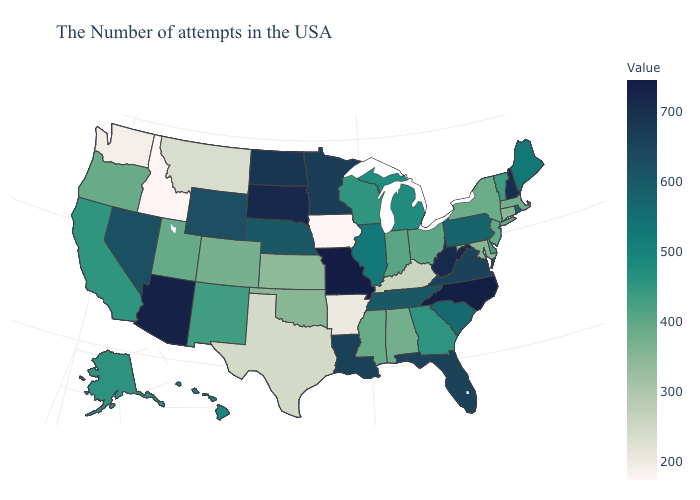Does Iowa have the lowest value in the USA?
Keep it brief. Yes. Does Iowa have the lowest value in the USA?
Short answer required. Yes. Is the legend a continuous bar?
Short answer required. Yes. Does Idaho have the lowest value in the USA?
Be succinct. Yes. Which states hav the highest value in the West?
Write a very short answer. Arizona. Which states have the lowest value in the South?
Be succinct. Arkansas. Which states hav the highest value in the West?
Answer briefly. Arizona. Does Tennessee have the highest value in the South?
Concise answer only. No. Which states have the lowest value in the USA?
Answer briefly. Iowa, Idaho. Does Delaware have the highest value in the South?
Give a very brief answer. No. 